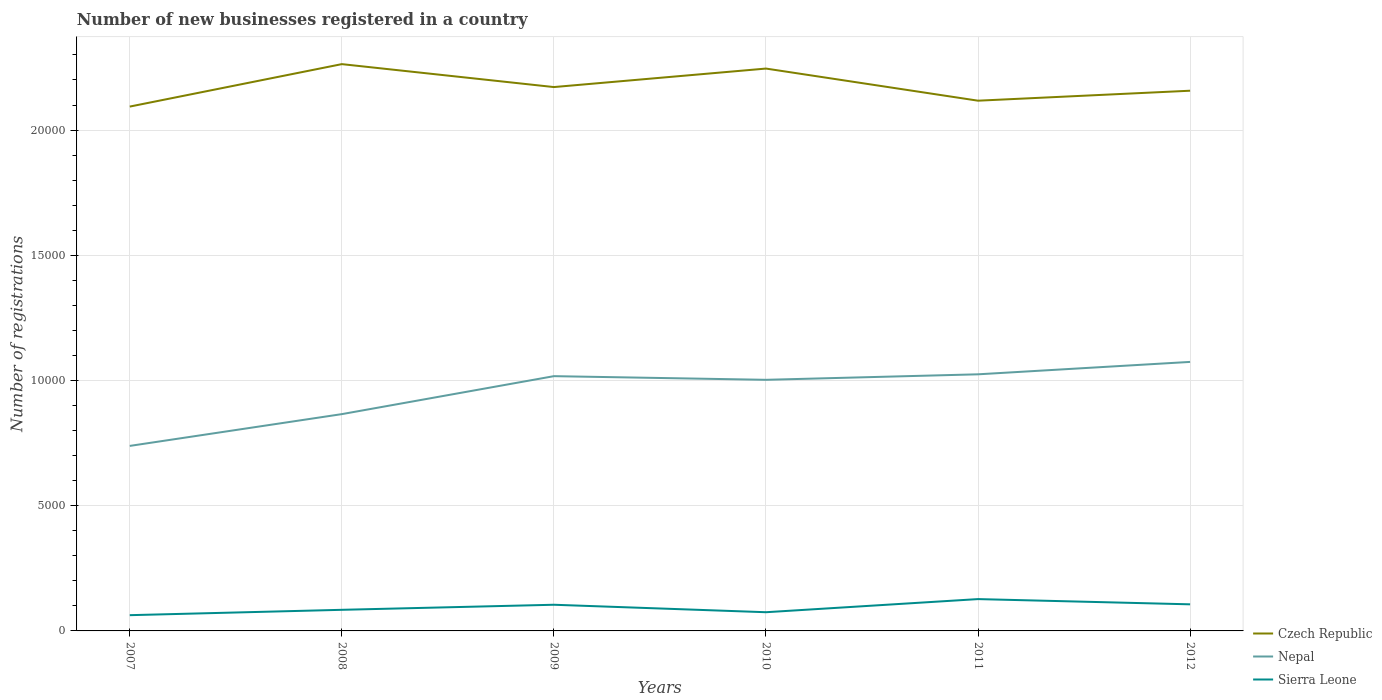Does the line corresponding to Czech Republic intersect with the line corresponding to Nepal?
Ensure brevity in your answer.  No. Across all years, what is the maximum number of new businesses registered in Sierra Leone?
Give a very brief answer. 629. In which year was the number of new businesses registered in Czech Republic maximum?
Provide a succinct answer. 2007. What is the total number of new businesses registered in Nepal in the graph?
Offer a terse response. -74. What is the difference between the highest and the second highest number of new businesses registered in Czech Republic?
Give a very brief answer. 1695. How many lines are there?
Offer a terse response. 3. Are the values on the major ticks of Y-axis written in scientific E-notation?
Your answer should be very brief. No. Does the graph contain grids?
Offer a very short reply. Yes. How many legend labels are there?
Provide a short and direct response. 3. How are the legend labels stacked?
Your answer should be very brief. Vertical. What is the title of the graph?
Make the answer very short. Number of new businesses registered in a country. What is the label or title of the X-axis?
Your answer should be compact. Years. What is the label or title of the Y-axis?
Provide a short and direct response. Number of registrations. What is the Number of registrations in Czech Republic in 2007?
Keep it short and to the point. 2.09e+04. What is the Number of registrations of Nepal in 2007?
Provide a succinct answer. 7388. What is the Number of registrations in Sierra Leone in 2007?
Offer a terse response. 629. What is the Number of registrations in Czech Republic in 2008?
Your answer should be very brief. 2.26e+04. What is the Number of registrations in Nepal in 2008?
Provide a short and direct response. 8657. What is the Number of registrations of Sierra Leone in 2008?
Make the answer very short. 843. What is the Number of registrations of Czech Republic in 2009?
Your answer should be compact. 2.17e+04. What is the Number of registrations of Nepal in 2009?
Provide a short and direct response. 1.02e+04. What is the Number of registrations of Sierra Leone in 2009?
Offer a terse response. 1045. What is the Number of registrations in Czech Republic in 2010?
Ensure brevity in your answer.  2.25e+04. What is the Number of registrations in Nepal in 2010?
Offer a terse response. 1.00e+04. What is the Number of registrations in Sierra Leone in 2010?
Offer a terse response. 747. What is the Number of registrations in Czech Republic in 2011?
Make the answer very short. 2.12e+04. What is the Number of registrations of Nepal in 2011?
Ensure brevity in your answer.  1.02e+04. What is the Number of registrations of Sierra Leone in 2011?
Your answer should be compact. 1271. What is the Number of registrations in Czech Republic in 2012?
Offer a very short reply. 2.16e+04. What is the Number of registrations of Nepal in 2012?
Keep it short and to the point. 1.07e+04. What is the Number of registrations of Sierra Leone in 2012?
Keep it short and to the point. 1062. Across all years, what is the maximum Number of registrations in Czech Republic?
Your answer should be compact. 2.26e+04. Across all years, what is the maximum Number of registrations in Nepal?
Provide a short and direct response. 1.07e+04. Across all years, what is the maximum Number of registrations of Sierra Leone?
Provide a succinct answer. 1271. Across all years, what is the minimum Number of registrations in Czech Republic?
Your response must be concise. 2.09e+04. Across all years, what is the minimum Number of registrations in Nepal?
Your answer should be compact. 7388. Across all years, what is the minimum Number of registrations of Sierra Leone?
Your answer should be compact. 629. What is the total Number of registrations of Czech Republic in the graph?
Keep it short and to the point. 1.30e+05. What is the total Number of registrations of Nepal in the graph?
Give a very brief answer. 5.72e+04. What is the total Number of registrations of Sierra Leone in the graph?
Make the answer very short. 5597. What is the difference between the Number of registrations in Czech Republic in 2007 and that in 2008?
Offer a terse response. -1695. What is the difference between the Number of registrations in Nepal in 2007 and that in 2008?
Offer a very short reply. -1269. What is the difference between the Number of registrations in Sierra Leone in 2007 and that in 2008?
Make the answer very short. -214. What is the difference between the Number of registrations of Czech Republic in 2007 and that in 2009?
Provide a short and direct response. -779. What is the difference between the Number of registrations in Nepal in 2007 and that in 2009?
Offer a terse response. -2785. What is the difference between the Number of registrations in Sierra Leone in 2007 and that in 2009?
Provide a short and direct response. -416. What is the difference between the Number of registrations in Czech Republic in 2007 and that in 2010?
Your answer should be very brief. -1518. What is the difference between the Number of registrations in Nepal in 2007 and that in 2010?
Your response must be concise. -2639. What is the difference between the Number of registrations in Sierra Leone in 2007 and that in 2010?
Provide a succinct answer. -118. What is the difference between the Number of registrations in Czech Republic in 2007 and that in 2011?
Provide a succinct answer. -235. What is the difference between the Number of registrations in Nepal in 2007 and that in 2011?
Keep it short and to the point. -2859. What is the difference between the Number of registrations in Sierra Leone in 2007 and that in 2011?
Your response must be concise. -642. What is the difference between the Number of registrations of Czech Republic in 2007 and that in 2012?
Give a very brief answer. -633. What is the difference between the Number of registrations of Nepal in 2007 and that in 2012?
Your answer should be very brief. -3354. What is the difference between the Number of registrations in Sierra Leone in 2007 and that in 2012?
Give a very brief answer. -433. What is the difference between the Number of registrations of Czech Republic in 2008 and that in 2009?
Ensure brevity in your answer.  916. What is the difference between the Number of registrations of Nepal in 2008 and that in 2009?
Make the answer very short. -1516. What is the difference between the Number of registrations of Sierra Leone in 2008 and that in 2009?
Give a very brief answer. -202. What is the difference between the Number of registrations of Czech Republic in 2008 and that in 2010?
Your response must be concise. 177. What is the difference between the Number of registrations of Nepal in 2008 and that in 2010?
Your answer should be very brief. -1370. What is the difference between the Number of registrations of Sierra Leone in 2008 and that in 2010?
Give a very brief answer. 96. What is the difference between the Number of registrations in Czech Republic in 2008 and that in 2011?
Make the answer very short. 1460. What is the difference between the Number of registrations in Nepal in 2008 and that in 2011?
Your answer should be compact. -1590. What is the difference between the Number of registrations in Sierra Leone in 2008 and that in 2011?
Give a very brief answer. -428. What is the difference between the Number of registrations of Czech Republic in 2008 and that in 2012?
Give a very brief answer. 1062. What is the difference between the Number of registrations of Nepal in 2008 and that in 2012?
Your answer should be very brief. -2085. What is the difference between the Number of registrations in Sierra Leone in 2008 and that in 2012?
Keep it short and to the point. -219. What is the difference between the Number of registrations in Czech Republic in 2009 and that in 2010?
Your answer should be very brief. -739. What is the difference between the Number of registrations of Nepal in 2009 and that in 2010?
Offer a very short reply. 146. What is the difference between the Number of registrations of Sierra Leone in 2009 and that in 2010?
Provide a short and direct response. 298. What is the difference between the Number of registrations of Czech Republic in 2009 and that in 2011?
Your answer should be compact. 544. What is the difference between the Number of registrations of Nepal in 2009 and that in 2011?
Your response must be concise. -74. What is the difference between the Number of registrations in Sierra Leone in 2009 and that in 2011?
Keep it short and to the point. -226. What is the difference between the Number of registrations in Czech Republic in 2009 and that in 2012?
Offer a terse response. 146. What is the difference between the Number of registrations in Nepal in 2009 and that in 2012?
Your answer should be compact. -569. What is the difference between the Number of registrations in Sierra Leone in 2009 and that in 2012?
Keep it short and to the point. -17. What is the difference between the Number of registrations of Czech Republic in 2010 and that in 2011?
Your answer should be compact. 1283. What is the difference between the Number of registrations in Nepal in 2010 and that in 2011?
Offer a terse response. -220. What is the difference between the Number of registrations in Sierra Leone in 2010 and that in 2011?
Provide a succinct answer. -524. What is the difference between the Number of registrations in Czech Republic in 2010 and that in 2012?
Your answer should be very brief. 885. What is the difference between the Number of registrations in Nepal in 2010 and that in 2012?
Your answer should be compact. -715. What is the difference between the Number of registrations in Sierra Leone in 2010 and that in 2012?
Your answer should be compact. -315. What is the difference between the Number of registrations of Czech Republic in 2011 and that in 2012?
Provide a short and direct response. -398. What is the difference between the Number of registrations of Nepal in 2011 and that in 2012?
Keep it short and to the point. -495. What is the difference between the Number of registrations of Sierra Leone in 2011 and that in 2012?
Keep it short and to the point. 209. What is the difference between the Number of registrations of Czech Republic in 2007 and the Number of registrations of Nepal in 2008?
Make the answer very short. 1.23e+04. What is the difference between the Number of registrations in Czech Republic in 2007 and the Number of registrations in Sierra Leone in 2008?
Your answer should be compact. 2.01e+04. What is the difference between the Number of registrations of Nepal in 2007 and the Number of registrations of Sierra Leone in 2008?
Your answer should be compact. 6545. What is the difference between the Number of registrations in Czech Republic in 2007 and the Number of registrations in Nepal in 2009?
Give a very brief answer. 1.08e+04. What is the difference between the Number of registrations in Czech Republic in 2007 and the Number of registrations in Sierra Leone in 2009?
Your response must be concise. 1.99e+04. What is the difference between the Number of registrations of Nepal in 2007 and the Number of registrations of Sierra Leone in 2009?
Keep it short and to the point. 6343. What is the difference between the Number of registrations in Czech Republic in 2007 and the Number of registrations in Nepal in 2010?
Provide a succinct answer. 1.09e+04. What is the difference between the Number of registrations in Czech Republic in 2007 and the Number of registrations in Sierra Leone in 2010?
Make the answer very short. 2.02e+04. What is the difference between the Number of registrations of Nepal in 2007 and the Number of registrations of Sierra Leone in 2010?
Your answer should be compact. 6641. What is the difference between the Number of registrations of Czech Republic in 2007 and the Number of registrations of Nepal in 2011?
Make the answer very short. 1.07e+04. What is the difference between the Number of registrations in Czech Republic in 2007 and the Number of registrations in Sierra Leone in 2011?
Offer a terse response. 1.97e+04. What is the difference between the Number of registrations in Nepal in 2007 and the Number of registrations in Sierra Leone in 2011?
Offer a terse response. 6117. What is the difference between the Number of registrations of Czech Republic in 2007 and the Number of registrations of Nepal in 2012?
Provide a short and direct response. 1.02e+04. What is the difference between the Number of registrations of Czech Republic in 2007 and the Number of registrations of Sierra Leone in 2012?
Your answer should be compact. 1.99e+04. What is the difference between the Number of registrations of Nepal in 2007 and the Number of registrations of Sierra Leone in 2012?
Offer a terse response. 6326. What is the difference between the Number of registrations in Czech Republic in 2008 and the Number of registrations in Nepal in 2009?
Make the answer very short. 1.25e+04. What is the difference between the Number of registrations in Czech Republic in 2008 and the Number of registrations in Sierra Leone in 2009?
Offer a terse response. 2.16e+04. What is the difference between the Number of registrations in Nepal in 2008 and the Number of registrations in Sierra Leone in 2009?
Your response must be concise. 7612. What is the difference between the Number of registrations of Czech Republic in 2008 and the Number of registrations of Nepal in 2010?
Ensure brevity in your answer.  1.26e+04. What is the difference between the Number of registrations of Czech Republic in 2008 and the Number of registrations of Sierra Leone in 2010?
Your response must be concise. 2.19e+04. What is the difference between the Number of registrations in Nepal in 2008 and the Number of registrations in Sierra Leone in 2010?
Keep it short and to the point. 7910. What is the difference between the Number of registrations in Czech Republic in 2008 and the Number of registrations in Nepal in 2011?
Your answer should be very brief. 1.24e+04. What is the difference between the Number of registrations of Czech Republic in 2008 and the Number of registrations of Sierra Leone in 2011?
Offer a terse response. 2.14e+04. What is the difference between the Number of registrations of Nepal in 2008 and the Number of registrations of Sierra Leone in 2011?
Your answer should be very brief. 7386. What is the difference between the Number of registrations of Czech Republic in 2008 and the Number of registrations of Nepal in 2012?
Offer a very short reply. 1.19e+04. What is the difference between the Number of registrations of Czech Republic in 2008 and the Number of registrations of Sierra Leone in 2012?
Offer a very short reply. 2.16e+04. What is the difference between the Number of registrations in Nepal in 2008 and the Number of registrations in Sierra Leone in 2012?
Provide a short and direct response. 7595. What is the difference between the Number of registrations in Czech Republic in 2009 and the Number of registrations in Nepal in 2010?
Your answer should be very brief. 1.17e+04. What is the difference between the Number of registrations in Czech Republic in 2009 and the Number of registrations in Sierra Leone in 2010?
Provide a succinct answer. 2.10e+04. What is the difference between the Number of registrations in Nepal in 2009 and the Number of registrations in Sierra Leone in 2010?
Offer a very short reply. 9426. What is the difference between the Number of registrations of Czech Republic in 2009 and the Number of registrations of Nepal in 2011?
Your answer should be very brief. 1.15e+04. What is the difference between the Number of registrations of Czech Republic in 2009 and the Number of registrations of Sierra Leone in 2011?
Keep it short and to the point. 2.04e+04. What is the difference between the Number of registrations in Nepal in 2009 and the Number of registrations in Sierra Leone in 2011?
Your response must be concise. 8902. What is the difference between the Number of registrations of Czech Republic in 2009 and the Number of registrations of Nepal in 2012?
Keep it short and to the point. 1.10e+04. What is the difference between the Number of registrations of Czech Republic in 2009 and the Number of registrations of Sierra Leone in 2012?
Your response must be concise. 2.07e+04. What is the difference between the Number of registrations of Nepal in 2009 and the Number of registrations of Sierra Leone in 2012?
Offer a terse response. 9111. What is the difference between the Number of registrations in Czech Republic in 2010 and the Number of registrations in Nepal in 2011?
Your response must be concise. 1.22e+04. What is the difference between the Number of registrations of Czech Republic in 2010 and the Number of registrations of Sierra Leone in 2011?
Ensure brevity in your answer.  2.12e+04. What is the difference between the Number of registrations in Nepal in 2010 and the Number of registrations in Sierra Leone in 2011?
Your answer should be very brief. 8756. What is the difference between the Number of registrations in Czech Republic in 2010 and the Number of registrations in Nepal in 2012?
Ensure brevity in your answer.  1.17e+04. What is the difference between the Number of registrations in Czech Republic in 2010 and the Number of registrations in Sierra Leone in 2012?
Provide a succinct answer. 2.14e+04. What is the difference between the Number of registrations of Nepal in 2010 and the Number of registrations of Sierra Leone in 2012?
Your answer should be compact. 8965. What is the difference between the Number of registrations of Czech Republic in 2011 and the Number of registrations of Nepal in 2012?
Keep it short and to the point. 1.04e+04. What is the difference between the Number of registrations in Czech Republic in 2011 and the Number of registrations in Sierra Leone in 2012?
Keep it short and to the point. 2.01e+04. What is the difference between the Number of registrations of Nepal in 2011 and the Number of registrations of Sierra Leone in 2012?
Your answer should be very brief. 9185. What is the average Number of registrations in Czech Republic per year?
Your answer should be compact. 2.17e+04. What is the average Number of registrations in Nepal per year?
Keep it short and to the point. 9539. What is the average Number of registrations in Sierra Leone per year?
Give a very brief answer. 932.83. In the year 2007, what is the difference between the Number of registrations in Czech Republic and Number of registrations in Nepal?
Provide a succinct answer. 1.36e+04. In the year 2007, what is the difference between the Number of registrations of Czech Republic and Number of registrations of Sierra Leone?
Make the answer very short. 2.03e+04. In the year 2007, what is the difference between the Number of registrations in Nepal and Number of registrations in Sierra Leone?
Provide a succinct answer. 6759. In the year 2008, what is the difference between the Number of registrations in Czech Republic and Number of registrations in Nepal?
Make the answer very short. 1.40e+04. In the year 2008, what is the difference between the Number of registrations in Czech Republic and Number of registrations in Sierra Leone?
Offer a terse response. 2.18e+04. In the year 2008, what is the difference between the Number of registrations in Nepal and Number of registrations in Sierra Leone?
Keep it short and to the point. 7814. In the year 2009, what is the difference between the Number of registrations in Czech Republic and Number of registrations in Nepal?
Your answer should be very brief. 1.15e+04. In the year 2009, what is the difference between the Number of registrations of Czech Republic and Number of registrations of Sierra Leone?
Ensure brevity in your answer.  2.07e+04. In the year 2009, what is the difference between the Number of registrations in Nepal and Number of registrations in Sierra Leone?
Ensure brevity in your answer.  9128. In the year 2010, what is the difference between the Number of registrations in Czech Republic and Number of registrations in Nepal?
Ensure brevity in your answer.  1.24e+04. In the year 2010, what is the difference between the Number of registrations in Czech Republic and Number of registrations in Sierra Leone?
Provide a short and direct response. 2.17e+04. In the year 2010, what is the difference between the Number of registrations of Nepal and Number of registrations of Sierra Leone?
Make the answer very short. 9280. In the year 2011, what is the difference between the Number of registrations of Czech Republic and Number of registrations of Nepal?
Ensure brevity in your answer.  1.09e+04. In the year 2011, what is the difference between the Number of registrations in Czech Republic and Number of registrations in Sierra Leone?
Provide a short and direct response. 1.99e+04. In the year 2011, what is the difference between the Number of registrations of Nepal and Number of registrations of Sierra Leone?
Make the answer very short. 8976. In the year 2012, what is the difference between the Number of registrations in Czech Republic and Number of registrations in Nepal?
Offer a terse response. 1.08e+04. In the year 2012, what is the difference between the Number of registrations of Czech Republic and Number of registrations of Sierra Leone?
Provide a succinct answer. 2.05e+04. In the year 2012, what is the difference between the Number of registrations in Nepal and Number of registrations in Sierra Leone?
Provide a short and direct response. 9680. What is the ratio of the Number of registrations of Czech Republic in 2007 to that in 2008?
Your response must be concise. 0.93. What is the ratio of the Number of registrations in Nepal in 2007 to that in 2008?
Your answer should be compact. 0.85. What is the ratio of the Number of registrations of Sierra Leone in 2007 to that in 2008?
Your answer should be compact. 0.75. What is the ratio of the Number of registrations in Czech Republic in 2007 to that in 2009?
Provide a short and direct response. 0.96. What is the ratio of the Number of registrations in Nepal in 2007 to that in 2009?
Provide a succinct answer. 0.73. What is the ratio of the Number of registrations of Sierra Leone in 2007 to that in 2009?
Your answer should be compact. 0.6. What is the ratio of the Number of registrations in Czech Republic in 2007 to that in 2010?
Provide a short and direct response. 0.93. What is the ratio of the Number of registrations in Nepal in 2007 to that in 2010?
Provide a succinct answer. 0.74. What is the ratio of the Number of registrations in Sierra Leone in 2007 to that in 2010?
Provide a succinct answer. 0.84. What is the ratio of the Number of registrations of Czech Republic in 2007 to that in 2011?
Your answer should be very brief. 0.99. What is the ratio of the Number of registrations in Nepal in 2007 to that in 2011?
Provide a short and direct response. 0.72. What is the ratio of the Number of registrations of Sierra Leone in 2007 to that in 2011?
Your answer should be very brief. 0.49. What is the ratio of the Number of registrations in Czech Republic in 2007 to that in 2012?
Keep it short and to the point. 0.97. What is the ratio of the Number of registrations of Nepal in 2007 to that in 2012?
Your answer should be very brief. 0.69. What is the ratio of the Number of registrations in Sierra Leone in 2007 to that in 2012?
Your answer should be very brief. 0.59. What is the ratio of the Number of registrations in Czech Republic in 2008 to that in 2009?
Offer a very short reply. 1.04. What is the ratio of the Number of registrations of Nepal in 2008 to that in 2009?
Ensure brevity in your answer.  0.85. What is the ratio of the Number of registrations of Sierra Leone in 2008 to that in 2009?
Offer a very short reply. 0.81. What is the ratio of the Number of registrations of Czech Republic in 2008 to that in 2010?
Offer a terse response. 1.01. What is the ratio of the Number of registrations of Nepal in 2008 to that in 2010?
Your answer should be compact. 0.86. What is the ratio of the Number of registrations of Sierra Leone in 2008 to that in 2010?
Offer a very short reply. 1.13. What is the ratio of the Number of registrations of Czech Republic in 2008 to that in 2011?
Your answer should be compact. 1.07. What is the ratio of the Number of registrations in Nepal in 2008 to that in 2011?
Keep it short and to the point. 0.84. What is the ratio of the Number of registrations in Sierra Leone in 2008 to that in 2011?
Make the answer very short. 0.66. What is the ratio of the Number of registrations of Czech Republic in 2008 to that in 2012?
Your answer should be compact. 1.05. What is the ratio of the Number of registrations in Nepal in 2008 to that in 2012?
Offer a very short reply. 0.81. What is the ratio of the Number of registrations of Sierra Leone in 2008 to that in 2012?
Offer a very short reply. 0.79. What is the ratio of the Number of registrations in Czech Republic in 2009 to that in 2010?
Your answer should be compact. 0.97. What is the ratio of the Number of registrations in Nepal in 2009 to that in 2010?
Give a very brief answer. 1.01. What is the ratio of the Number of registrations of Sierra Leone in 2009 to that in 2010?
Your answer should be very brief. 1.4. What is the ratio of the Number of registrations in Czech Republic in 2009 to that in 2011?
Offer a terse response. 1.03. What is the ratio of the Number of registrations in Sierra Leone in 2009 to that in 2011?
Give a very brief answer. 0.82. What is the ratio of the Number of registrations in Czech Republic in 2009 to that in 2012?
Your answer should be very brief. 1.01. What is the ratio of the Number of registrations in Nepal in 2009 to that in 2012?
Offer a terse response. 0.95. What is the ratio of the Number of registrations of Czech Republic in 2010 to that in 2011?
Keep it short and to the point. 1.06. What is the ratio of the Number of registrations in Nepal in 2010 to that in 2011?
Your answer should be compact. 0.98. What is the ratio of the Number of registrations in Sierra Leone in 2010 to that in 2011?
Your answer should be compact. 0.59. What is the ratio of the Number of registrations of Czech Republic in 2010 to that in 2012?
Make the answer very short. 1.04. What is the ratio of the Number of registrations of Nepal in 2010 to that in 2012?
Provide a succinct answer. 0.93. What is the ratio of the Number of registrations in Sierra Leone in 2010 to that in 2012?
Your answer should be very brief. 0.7. What is the ratio of the Number of registrations of Czech Republic in 2011 to that in 2012?
Ensure brevity in your answer.  0.98. What is the ratio of the Number of registrations of Nepal in 2011 to that in 2012?
Offer a terse response. 0.95. What is the ratio of the Number of registrations of Sierra Leone in 2011 to that in 2012?
Ensure brevity in your answer.  1.2. What is the difference between the highest and the second highest Number of registrations in Czech Republic?
Your answer should be compact. 177. What is the difference between the highest and the second highest Number of registrations in Nepal?
Keep it short and to the point. 495. What is the difference between the highest and the second highest Number of registrations in Sierra Leone?
Your answer should be compact. 209. What is the difference between the highest and the lowest Number of registrations in Czech Republic?
Give a very brief answer. 1695. What is the difference between the highest and the lowest Number of registrations in Nepal?
Your response must be concise. 3354. What is the difference between the highest and the lowest Number of registrations in Sierra Leone?
Offer a very short reply. 642. 